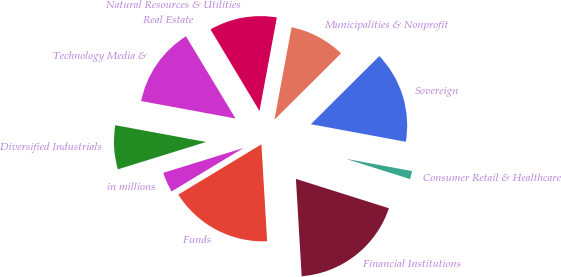Convert chart. <chart><loc_0><loc_0><loc_500><loc_500><pie_chart><fcel>in millions<fcel>Funds<fcel>Financial Institutions<fcel>Consumer Retail & Healthcare<fcel>Sovereign<fcel>Municipalities & Nonprofit<fcel>Natural Resources & Utilities<fcel>Real Estate<fcel>Technology Media &<fcel>Diversified Industrials<nl><fcel>3.87%<fcel>17.28%<fcel>19.2%<fcel>1.95%<fcel>15.37%<fcel>9.62%<fcel>11.53%<fcel>0.03%<fcel>13.45%<fcel>7.7%<nl></chart> 